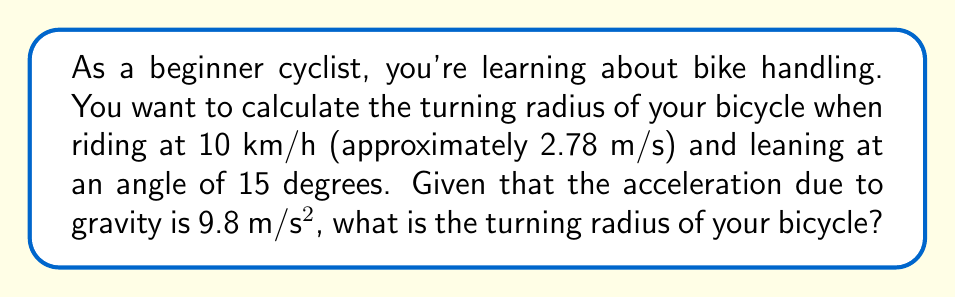What is the answer to this math problem? To solve this problem, we'll use the equation for the turning radius of a bicycle, which relates the speed, lean angle, and gravitational acceleration. The equation is:

$$R = \frac{v^2}{g \tan(\theta)}$$

Where:
$R$ = turning radius (in meters)
$v$ = velocity (in m/s)
$g$ = acceleration due to gravity (9.8 m/s²)
$\theta$ = lean angle (in degrees)

Let's plug in the values we know:
$v = 2.78$ m/s (converted from 10 km/h)
$g = 9.8$ m/s²
$\theta = 15°$

First, we need to convert the lean angle from degrees to radians:
$$15° \times \frac{\pi}{180°} \approx 0.2618 \text{ radians}$$

Now, let's substitute these values into the equation:

$$R = \frac{(2.78 \text{ m/s})^2}{(9.8 \text{ m/s}^2) \tan(0.2618)}$$

$$R = \frac{7.7284 \text{ m}^2\text{/s}^2}{9.8 \text{ m/s}^2 \times 0.2679}$$

$$R = \frac{7.7284}{2.6254} \text{ m}$$

$$R \approx 2.94 \text{ m}$$

Therefore, the turning radius of your bicycle under these conditions is approximately 2.94 meters.
Answer: $R \approx 2.94 \text{ m}$ 